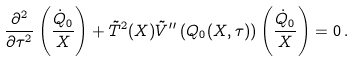<formula> <loc_0><loc_0><loc_500><loc_500>\frac { \partial ^ { 2 } } { \partial \tau ^ { 2 } } \left ( \frac { \dot { Q } _ { 0 } } { X } \right ) + \tilde { T } ^ { 2 } ( X ) \tilde { V } ^ { \prime \prime } \left ( Q _ { 0 } ( X , \tau ) \right ) \left ( \frac { \dot { Q } _ { 0 } } { X } \right ) = 0 \, .</formula> 